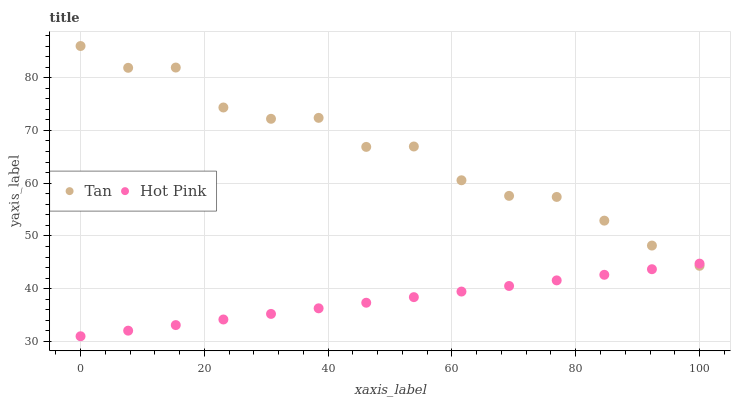Does Hot Pink have the minimum area under the curve?
Answer yes or no. Yes. Does Tan have the maximum area under the curve?
Answer yes or no. Yes. Does Hot Pink have the maximum area under the curve?
Answer yes or no. No. Is Hot Pink the smoothest?
Answer yes or no. Yes. Is Tan the roughest?
Answer yes or no. Yes. Is Hot Pink the roughest?
Answer yes or no. No. Does Hot Pink have the lowest value?
Answer yes or no. Yes. Does Tan have the highest value?
Answer yes or no. Yes. Does Hot Pink have the highest value?
Answer yes or no. No. Does Tan intersect Hot Pink?
Answer yes or no. Yes. Is Tan less than Hot Pink?
Answer yes or no. No. Is Tan greater than Hot Pink?
Answer yes or no. No. 